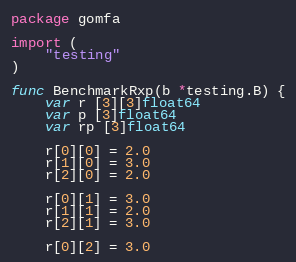Convert code to text. <code><loc_0><loc_0><loc_500><loc_500><_Go_>package gomfa

import (
	"testing"
)

func BenchmarkRxp(b *testing.B) {
	var r [3][3]float64
	var p [3]float64
	var rp [3]float64

	r[0][0] = 2.0
	r[1][0] = 3.0
	r[2][0] = 2.0

	r[0][1] = 3.0
	r[1][1] = 2.0
	r[2][1] = 3.0

	r[0][2] = 3.0</code> 